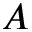<formula> <loc_0><loc_0><loc_500><loc_500>A</formula> 